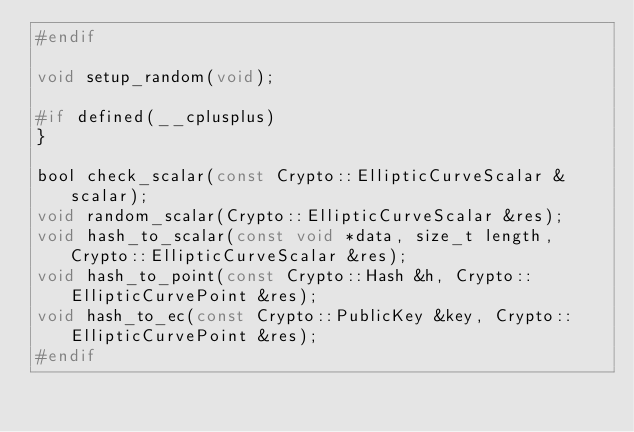Convert code to text. <code><loc_0><loc_0><loc_500><loc_500><_C_>#endif

void setup_random(void);

#if defined(__cplusplus)
}

bool check_scalar(const Crypto::EllipticCurveScalar &scalar);
void random_scalar(Crypto::EllipticCurveScalar &res);
void hash_to_scalar(const void *data, size_t length, Crypto::EllipticCurveScalar &res);
void hash_to_point(const Crypto::Hash &h, Crypto::EllipticCurvePoint &res);
void hash_to_ec(const Crypto::PublicKey &key, Crypto::EllipticCurvePoint &res);
#endif
</code> 